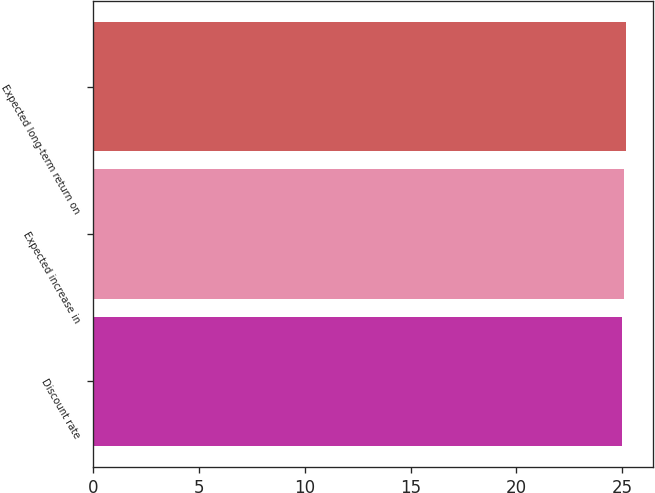Convert chart. <chart><loc_0><loc_0><loc_500><loc_500><bar_chart><fcel>Discount rate<fcel>Expected increase in<fcel>Expected long-term return on<nl><fcel>25<fcel>25.1<fcel>25.2<nl></chart> 